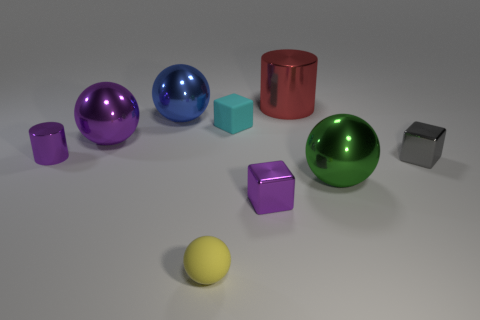Subtract all blue balls. How many balls are left? 3 Subtract all blue balls. How many balls are left? 3 Subtract 1 cubes. How many cubes are left? 2 Subtract all cylinders. How many objects are left? 7 Subtract all rubber objects. Subtract all tiny purple blocks. How many objects are left? 6 Add 9 blue objects. How many blue objects are left? 10 Add 9 small yellow rubber balls. How many small yellow rubber balls exist? 10 Subtract 1 purple spheres. How many objects are left? 8 Subtract all blue spheres. Subtract all gray cylinders. How many spheres are left? 3 